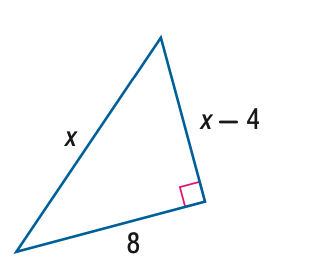Answer the mathemtical geometry problem and directly provide the correct option letter.
Question: Find x.
Choices: A: 8 B: 9 C: 10 D: 11 C 